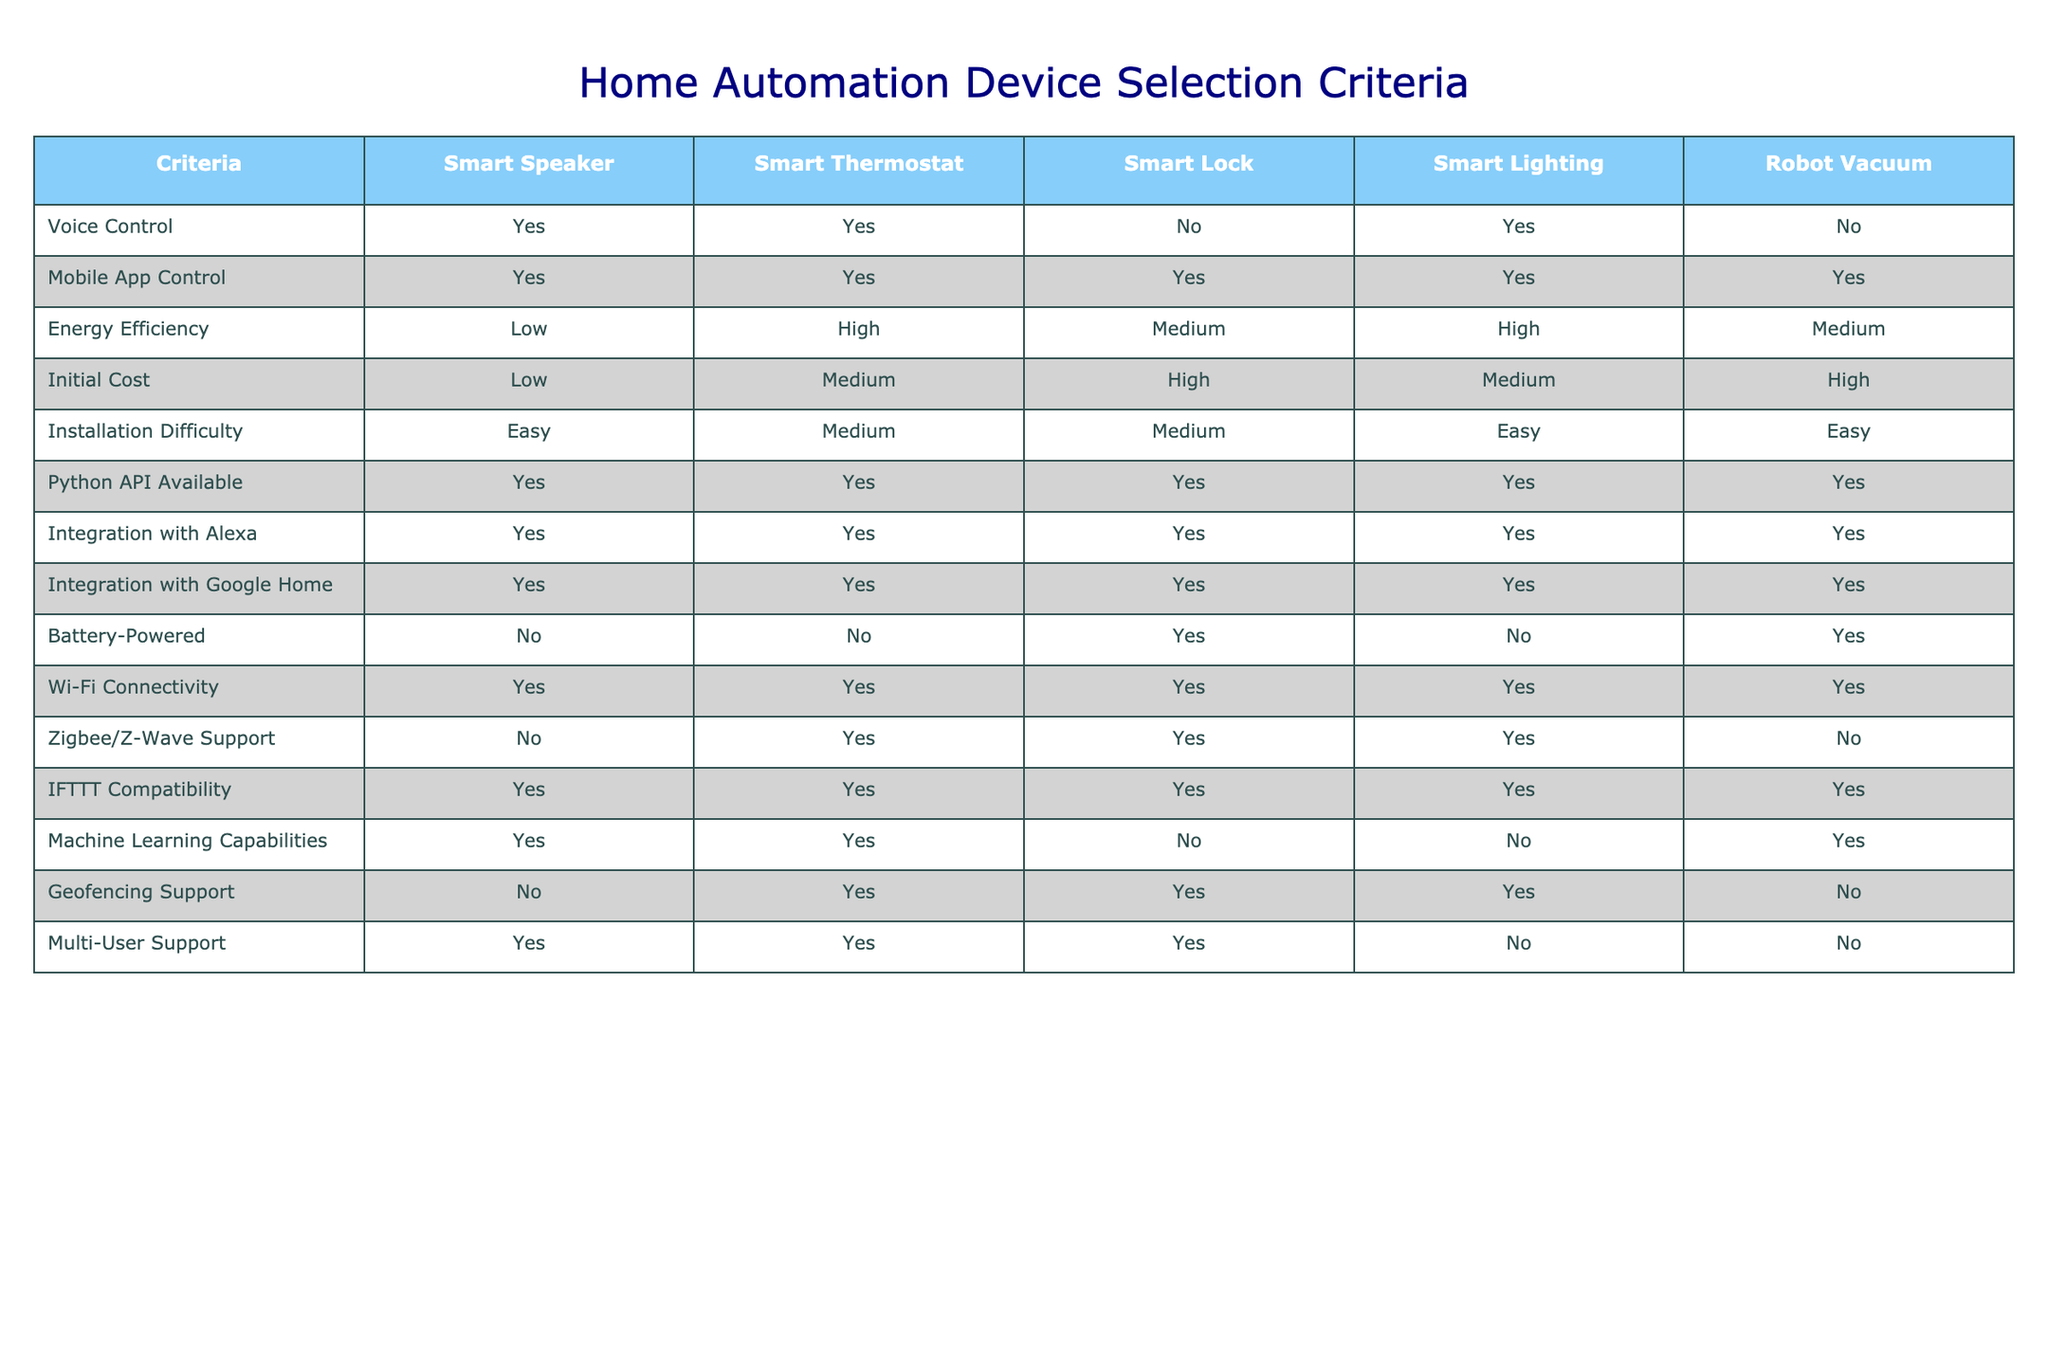What home automation device has the highest energy efficiency? By looking at the 'Energy Efficiency' row, the 'Smart Thermostat' and 'Smart Lighting' both have 'High' listed. When considering that 'Smart Thermostat' has a higher efficiency than 'Medium' which was designated for both 'Smart Lock' and 'Robot Vacuum', it confirms that these two devices are the top choice.
Answer: Smart Thermostat and Smart Lighting Which devices support IFTTT compatibility? In the IFTTT Compatibility row, all devices: Smart Speaker, Smart Thermostat, Smart Lock, Smart Lighting, and Robot Vacuum are shown to have 'Yes' under this criterion, indicating that they all support IFTTT.
Answer: All devices Is the Smart Lock battery-powered? The 'Battery-Powered' row indicates that 'Smart Lock' has 'Yes' listed under its name, showing it is indeed battery-powered.
Answer: Yes How many devices have mobile app control? By counting the entries in the 'Mobile App Control' row, all listed devices, which are five in total, have 'Yes' marked, confirming that they all support mobile app control.
Answer: 5 What is the average initial cost of the devices listed? The costs associated with the devices are Low (Smart Speaker), Medium (Smart Thermostat), High (Smart Lock), Medium (Smart Lighting), and High (Robot Vacuum). Converting these to numerical values (Low=1, Medium=2, High=3), we have (1 + 2 + 3 + 2 + 3) = 11. Dividing by the total number of devices (5), we get an average of 11/5 = 2.2, which translates to about Medium cost.
Answer: Medium Does the Smart Speaker have geofencing support? In the 'Geofencing Support' row, 'Smart Speaker' has 'No' listed, indicating it does not support geofencing.
Answer: No What is the installation difficulty of the Smart Lighting? Looking at the 'Installation Difficulty' row, 'Smart Lighting' is classified as 'Easy', suggesting it has a straightforward installation process.
Answer: Easy Which device has machine learning capabilities and also supports voice control? From the 'Machine Learning Capabilities' row, 'Smart Speaker' and 'Robot Vacuum' both have 'Yes'. Then checking the 'Voice Control' row, 'Smart Speaker' has 'Yes' while 'Robot Vacuum' has 'No', confirming 'Smart Speaker' is the only device meeting both criteria.
Answer: Smart Speaker How many devices integrate with both Alexa and Google Home? All devices have 'Yes' in both the 'Integration with Alexa' and 'Integration with Google Home' rows, indicating that there are a total of five devices that integrate with both platforms.
Answer: 5 